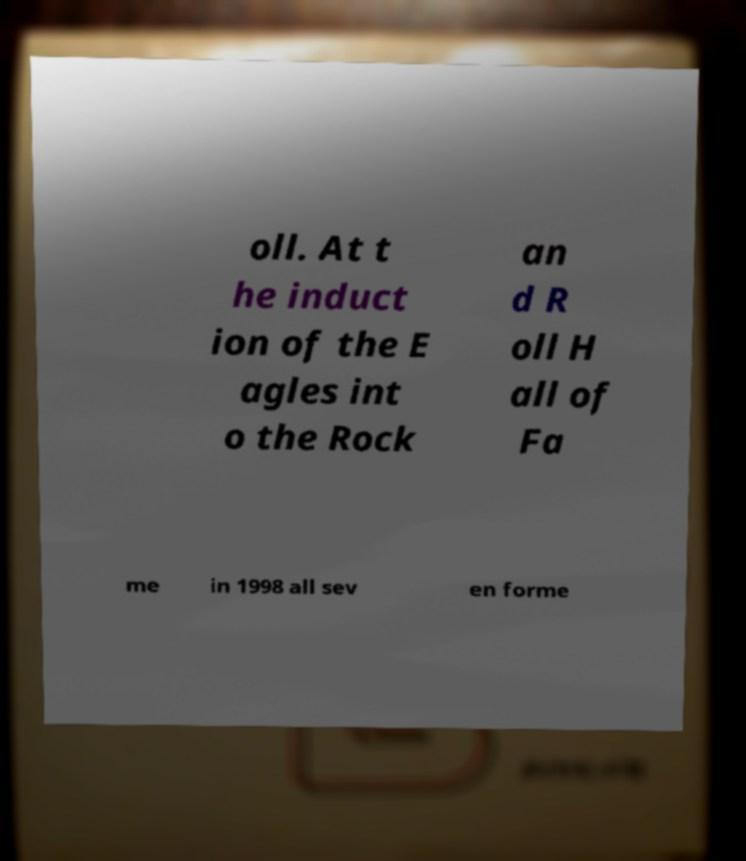Could you assist in decoding the text presented in this image and type it out clearly? oll. At t he induct ion of the E agles int o the Rock an d R oll H all of Fa me in 1998 all sev en forme 